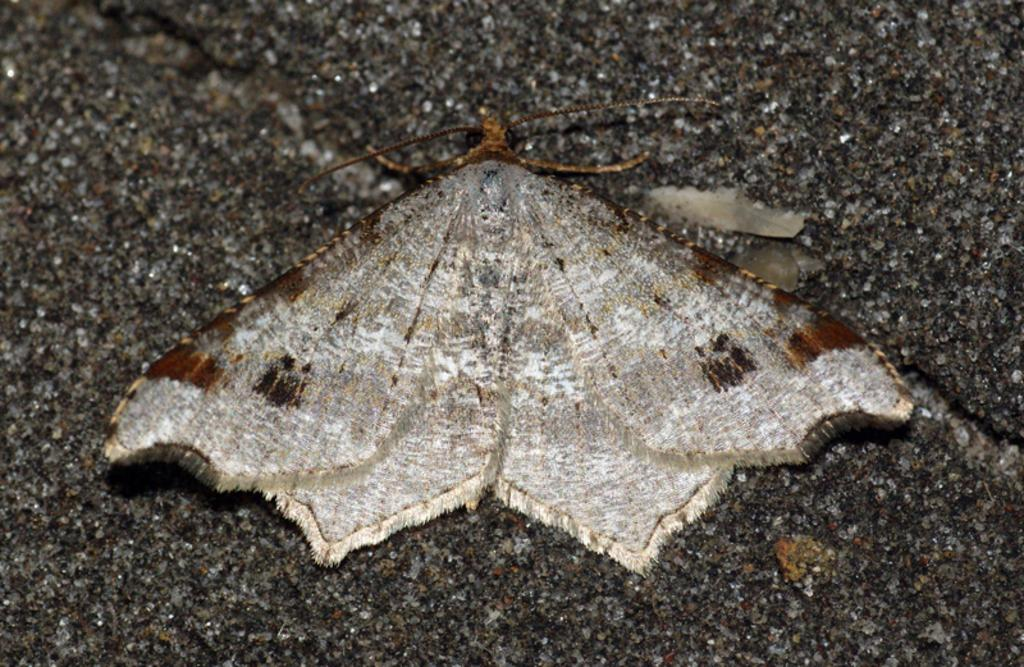What type of insect is in the image? There is a brown house moth in the image. What is the house moth resting on? The house moth is on a concrete material. How many kittens are playing with the stone in the image? There are no kittens or stones present in the image; it features a brown house moth on a concrete material. 